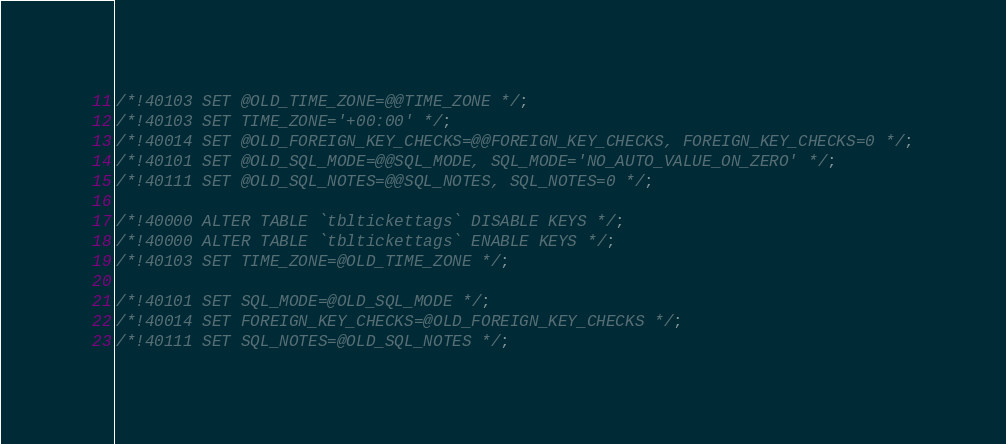<code> <loc_0><loc_0><loc_500><loc_500><_SQL_>/*!40103 SET @OLD_TIME_ZONE=@@TIME_ZONE */;
/*!40103 SET TIME_ZONE='+00:00' */;
/*!40014 SET @OLD_FOREIGN_KEY_CHECKS=@@FOREIGN_KEY_CHECKS, FOREIGN_KEY_CHECKS=0 */;
/*!40101 SET @OLD_SQL_MODE=@@SQL_MODE, SQL_MODE='NO_AUTO_VALUE_ON_ZERO' */;
/*!40111 SET @OLD_SQL_NOTES=@@SQL_NOTES, SQL_NOTES=0 */;

/*!40000 ALTER TABLE `tbltickettags` DISABLE KEYS */;
/*!40000 ALTER TABLE `tbltickettags` ENABLE KEYS */;
/*!40103 SET TIME_ZONE=@OLD_TIME_ZONE */;

/*!40101 SET SQL_MODE=@OLD_SQL_MODE */;
/*!40014 SET FOREIGN_KEY_CHECKS=@OLD_FOREIGN_KEY_CHECKS */;
/*!40111 SET SQL_NOTES=@OLD_SQL_NOTES */;

</code> 